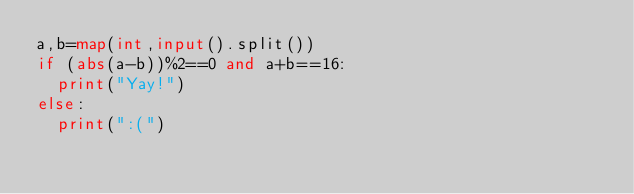<code> <loc_0><loc_0><loc_500><loc_500><_Python_>a,b=map(int,input().split())
if (abs(a-b))%2==0 and a+b==16:
  print("Yay!")
else:
  print(":(")</code> 